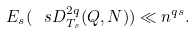Convert formula to latex. <formula><loc_0><loc_0><loc_500><loc_500>E _ { s } ( \ s D ^ { 2 q } _ { T _ { s } } ( Q , N ) ) \ll n ^ { q s } .</formula> 